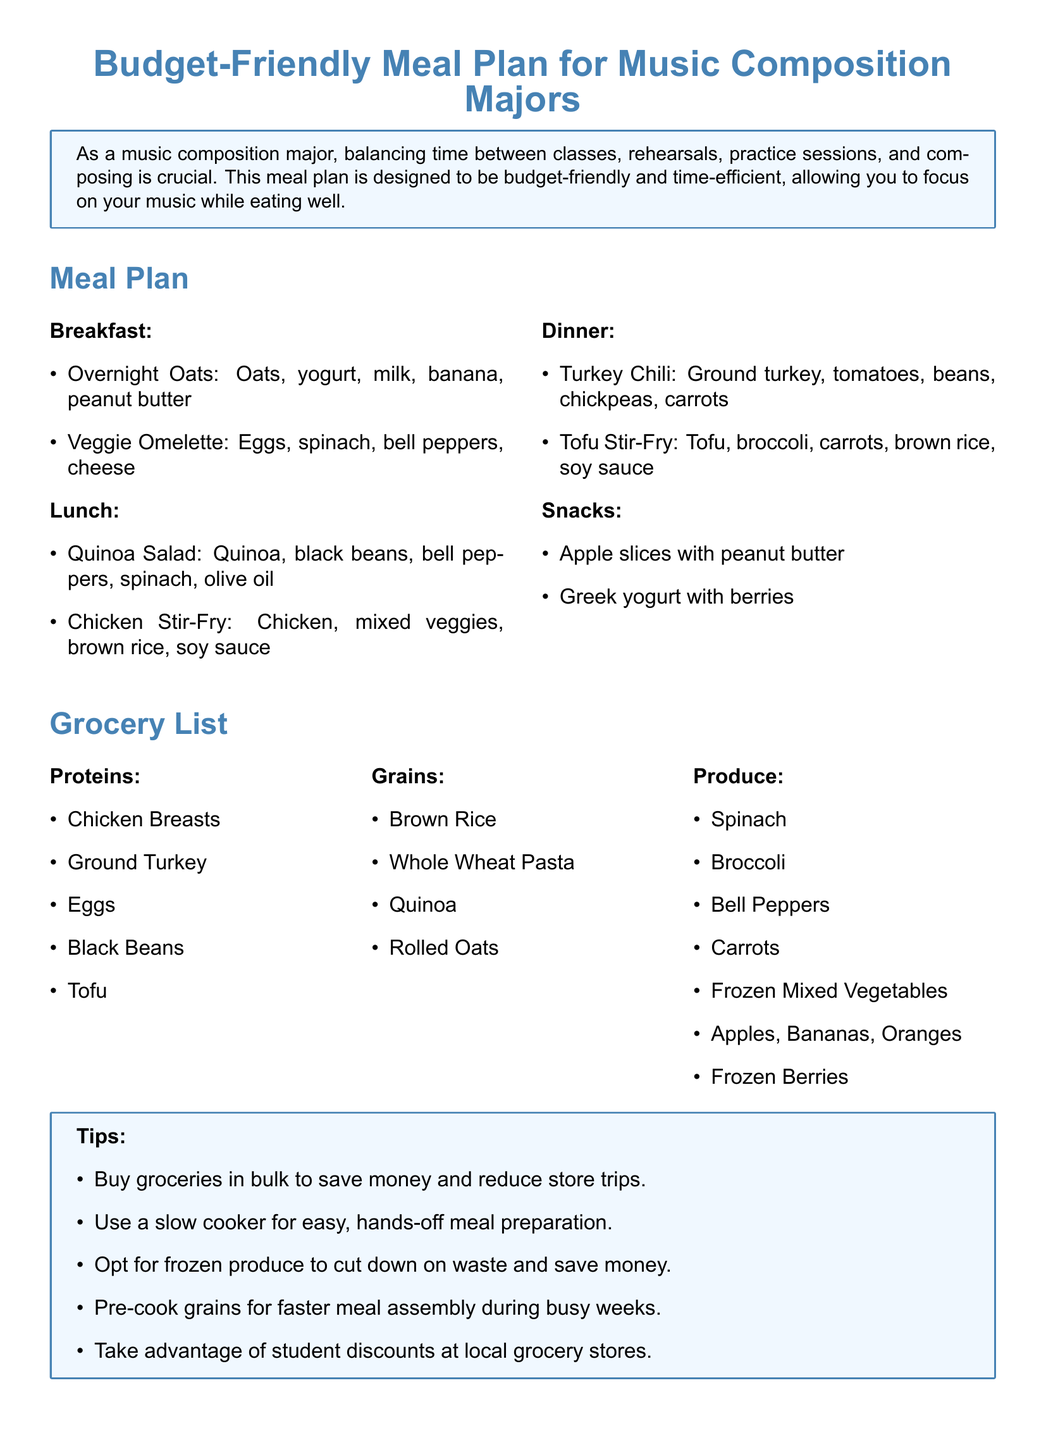What is the budget-friendly meal plan designed for? The meal plan is designed for music composition majors to help balance time between classes, rehearsals, practice sessions, and composing.
Answer: Music composition majors What is included in the breakfast options? The breakfast options include Overnight Oats and Veggie Omelette.
Answer: Overnight Oats and Veggie Omelette How many protein sources are listed in the grocery list? The grocery list includes five protein sources: Chicken Breasts, Ground Turkey, Eggs, Black Beans, Tofu.
Answer: Five Which grain is included in both meals and the grocery list? The grain found in both meals and the grocery list is brown rice.
Answer: Brown Rice What type of vegetables are suggested for a stir-fry in the lunch options? The suggested vegetables for the stir-fry are mixed veggies.
Answer: Mixed veggies What is one tip provided for saving money on groceries? One tip provided is to buy groceries in bulk to save money and reduce store trips.
Answer: Buy groceries in bulk How many different types of produce are listed in the grocery list? The grocery list includes seven types of produce, such as Spinach, Broccoli, Bell Peppers, and more.
Answer: Seven Which breakfast option includes yogurt? The breakfast option that includes yogurt is Overnight Oats.
Answer: Overnight Oats What is one advantage of using frozen produce according to the tips? Using frozen produce helps cut down on waste and save money.
Answer: Cut down on waste and save money 